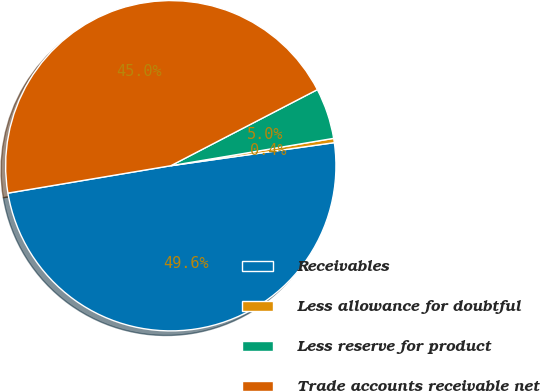Convert chart to OTSL. <chart><loc_0><loc_0><loc_500><loc_500><pie_chart><fcel>Receivables<fcel>Less allowance for doubtful<fcel>Less reserve for product<fcel>Trade accounts receivable net<nl><fcel>49.58%<fcel>0.42%<fcel>4.97%<fcel>45.03%<nl></chart> 